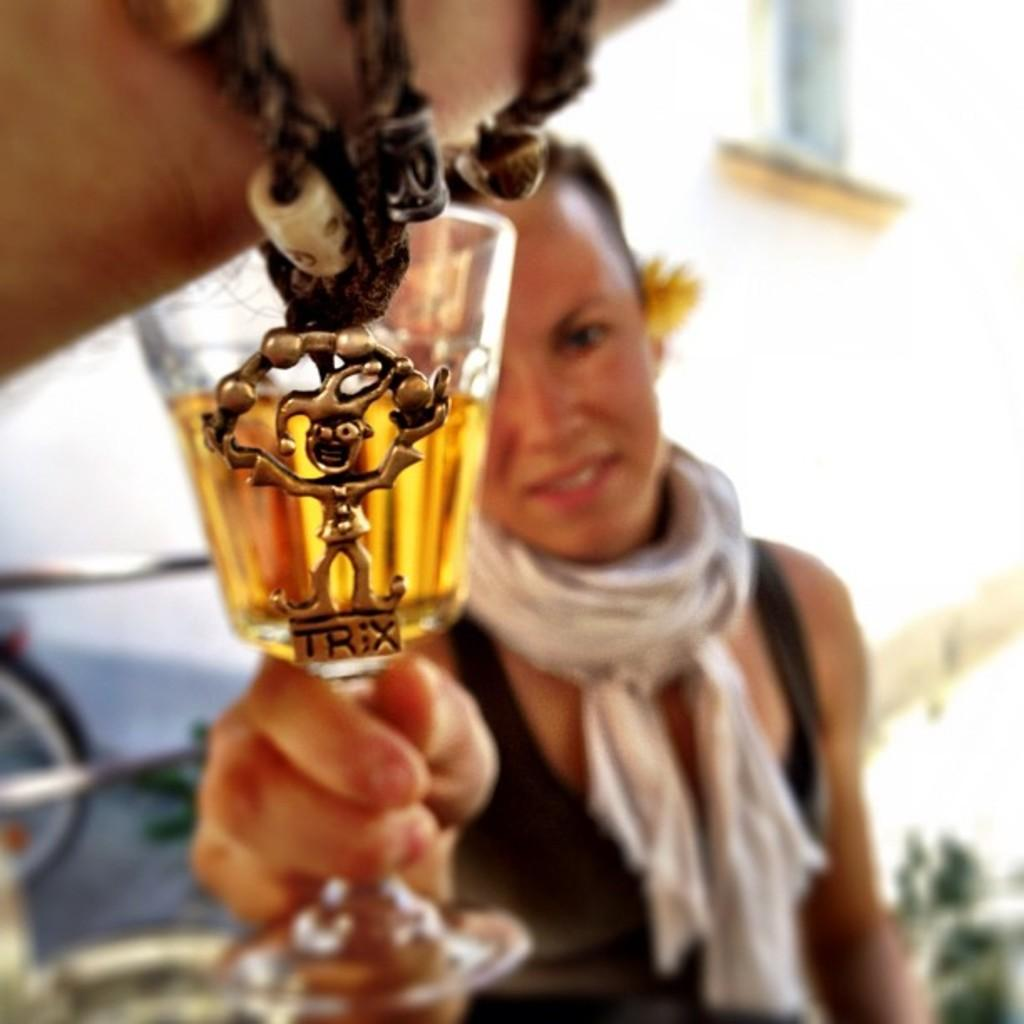What is the lady in the image wearing? The lady is wearing a black dress. What is the lady doing in the image? The lady is sitting. What is around the lady's neck? There is a stole around her neck. What is the lady holding in her hand? The lady is holding a glass in her hand. What can be seen in the top left corner of the image? In the top left corner of the image, there is a hand band with a toy. How many books can be seen on the stove in the image? There are no books or stoves present in the image. 